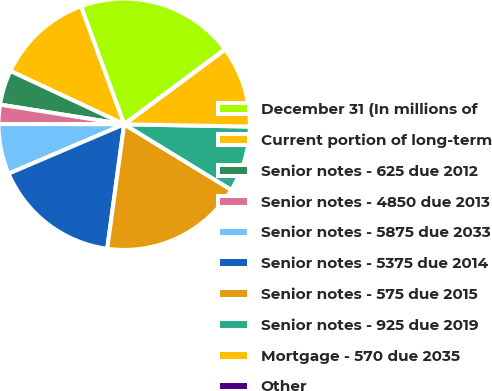Convert chart. <chart><loc_0><loc_0><loc_500><loc_500><pie_chart><fcel>December 31 (In millions of<fcel>Current portion of long-term<fcel>Senior notes - 625 due 2012<fcel>Senior notes - 4850 due 2013<fcel>Senior notes - 5875 due 2033<fcel>Senior notes - 5375 due 2014<fcel>Senior notes - 575 due 2015<fcel>Senior notes - 925 due 2019<fcel>Mortgage - 570 due 2035<fcel>Other<nl><fcel>20.41%<fcel>12.44%<fcel>4.47%<fcel>2.47%<fcel>6.46%<fcel>16.42%<fcel>18.41%<fcel>8.45%<fcel>10.44%<fcel>0.03%<nl></chart> 